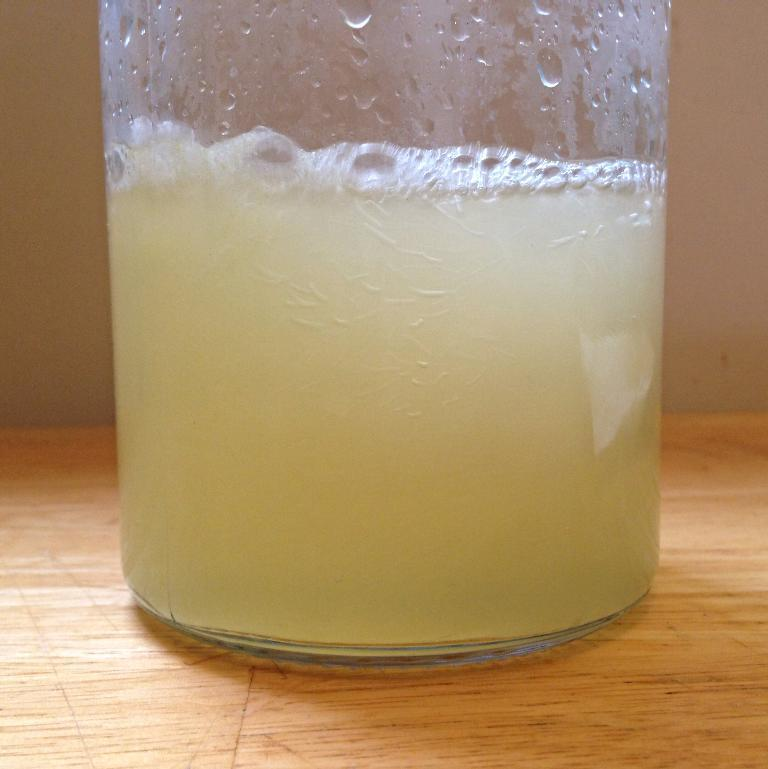What is located in the foreground of the picture? There is a glass in the foreground of the picture. What is inside the glass? There is a drink in the glass. What is the glass placed on? The glass is placed on a wooden table. Can you describe the background of the image? There might be a wall in the background of the image. What type of veil can be seen covering the drink in the glass? There is no veil present in the image; the drink is visible in the glass. How many parcels are visible on the wooden table? There are no parcels visible in the image; only a glass with a drink is present on the wooden table. 